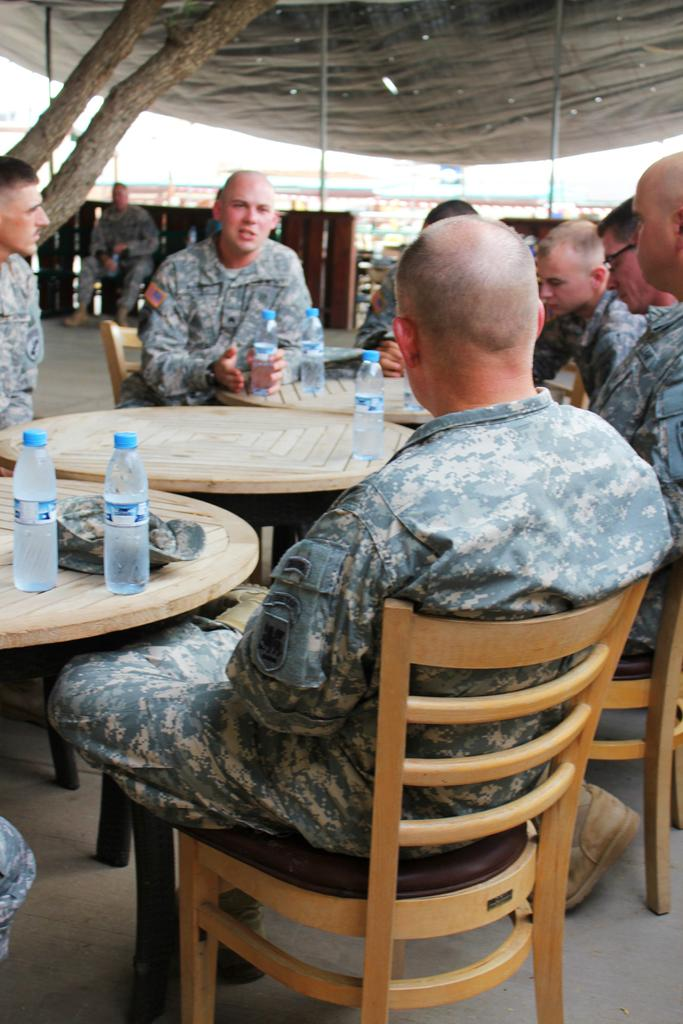What are the people in the image doing? People are sitting in the image. What are the people wearing? The people are wearing uniforms. How are the people arranged in the image? The people are seated around tables and chairs. What can be seen on the tables in the image? There are water bottles and a cap on the tables. What is visible in the background of the image? A tree trunk is visible in the background. What type of operation is being performed by the people in the image? There is no operation being performed in the image; the people are simply sitting. Can you tell me how many kitties are walking on the sidewalk in the image? There are no kitties or sidewalks present in the image. 